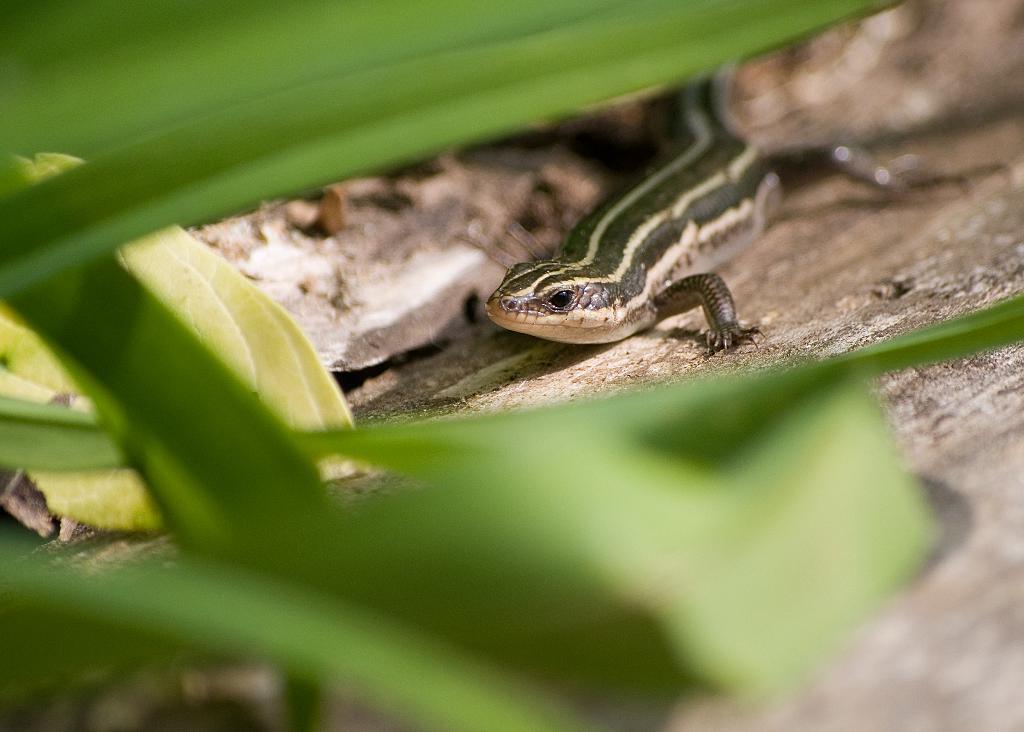Can you describe this image briefly? In this picture I can see a lizard and few green color leaves. 